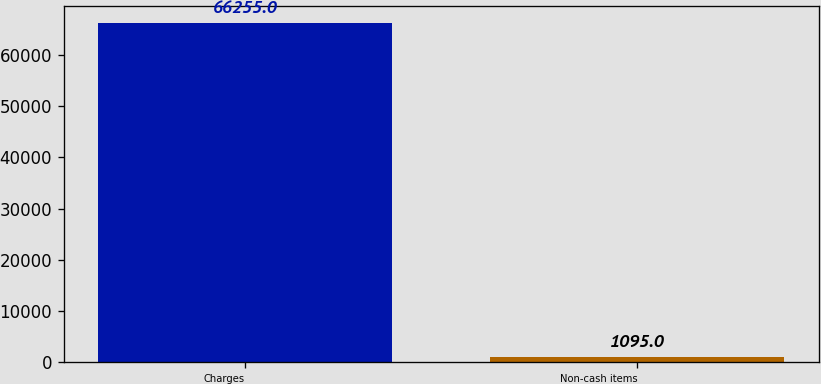Convert chart. <chart><loc_0><loc_0><loc_500><loc_500><bar_chart><fcel>Charges<fcel>Non-cash items<nl><fcel>66255<fcel>1095<nl></chart> 